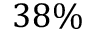Convert formula to latex. <formula><loc_0><loc_0><loc_500><loc_500>3 8 \%</formula> 